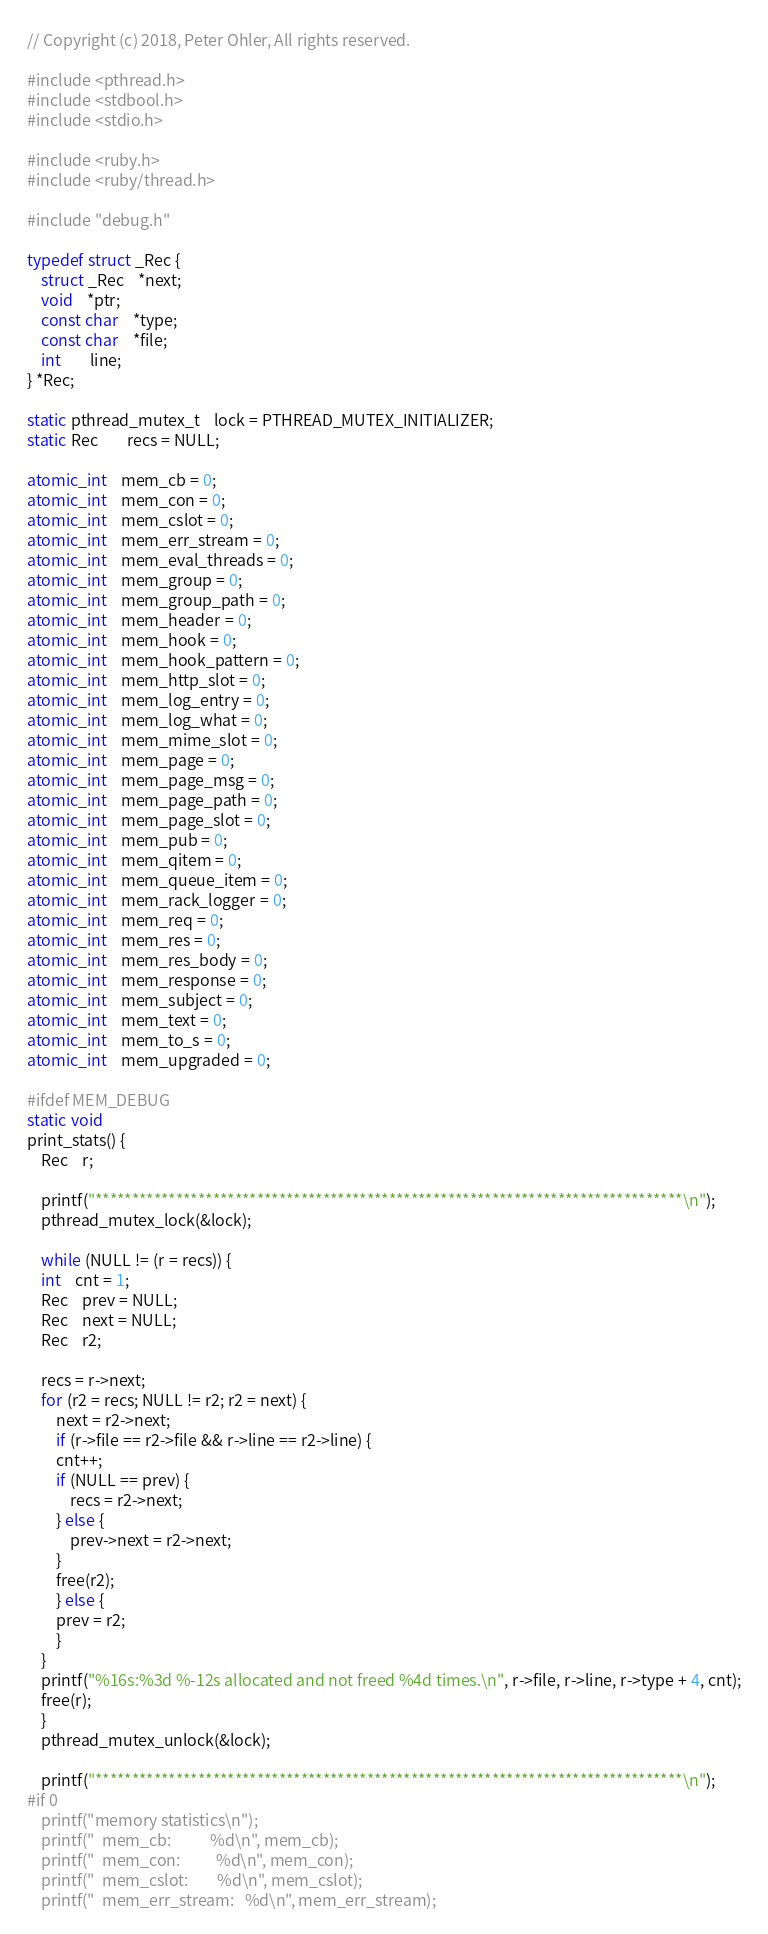Convert code to text. <code><loc_0><loc_0><loc_500><loc_500><_C_>// Copyright (c) 2018, Peter Ohler, All rights reserved.

#include <pthread.h>
#include <stdbool.h>
#include <stdio.h>

#include <ruby.h>
#include <ruby/thread.h>

#include "debug.h"

typedef struct _Rec {
    struct _Rec	*next;
    void	*ptr;
    const char	*type;
    const char	*file;
    int		line;
} *Rec;

static pthread_mutex_t	lock = PTHREAD_MUTEX_INITIALIZER;
static Rec		recs = NULL;

atomic_int	mem_cb = 0;
atomic_int	mem_con = 0;
atomic_int	mem_cslot = 0;
atomic_int	mem_err_stream = 0;
atomic_int	mem_eval_threads = 0;
atomic_int	mem_group = 0;
atomic_int	mem_group_path = 0;
atomic_int	mem_header = 0;
atomic_int	mem_hook = 0;
atomic_int	mem_hook_pattern = 0;
atomic_int	mem_http_slot = 0;
atomic_int	mem_log_entry = 0;
atomic_int	mem_log_what = 0;
atomic_int	mem_mime_slot = 0;
atomic_int	mem_page = 0;
atomic_int	mem_page_msg = 0;
atomic_int	mem_page_path = 0;
atomic_int	mem_page_slot = 0;
atomic_int	mem_pub = 0;
atomic_int	mem_qitem = 0;
atomic_int	mem_queue_item = 0;
atomic_int	mem_rack_logger = 0;
atomic_int	mem_req = 0;
atomic_int	mem_res = 0;
atomic_int	mem_res_body = 0;
atomic_int	mem_response = 0;
atomic_int	mem_subject = 0;
atomic_int	mem_text = 0;
atomic_int	mem_to_s = 0;
atomic_int	mem_upgraded = 0;

#ifdef MEM_DEBUG
static void
print_stats() {
    Rec	r;

    printf("********************************************************************************\n");
    pthread_mutex_lock(&lock);

    while (NULL != (r = recs)) {
	int	cnt = 1;
	Rec	prev = NULL;
	Rec	next = NULL;
	Rec	r2;
	
	recs = r->next;
	for (r2 = recs; NULL != r2; r2 = next) {
	    next = r2->next;
	    if (r->file == r2->file && r->line == r2->line) {
		cnt++;
		if (NULL == prev) {
		    recs = r2->next;
		} else {
		    prev->next = r2->next;
		}
		free(r2);
	    } else {
		prev = r2;
	    }
	}
	printf("%16s:%3d %-12s allocated and not freed %4d times.\n", r->file, r->line, r->type + 4, cnt);
	free(r);
    }
    pthread_mutex_unlock(&lock);	

    printf("********************************************************************************\n");
#if 0
    printf("memory statistics\n");
    printf("  mem_cb:           %d\n", mem_cb);
    printf("  mem_con:          %d\n", mem_con);
    printf("  mem_cslot:        %d\n", mem_cslot);
    printf("  mem_err_stream:   %d\n", mem_err_stream);</code> 